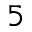Convert formula to latex. <formula><loc_0><loc_0><loc_500><loc_500>^ { 5 }</formula> 